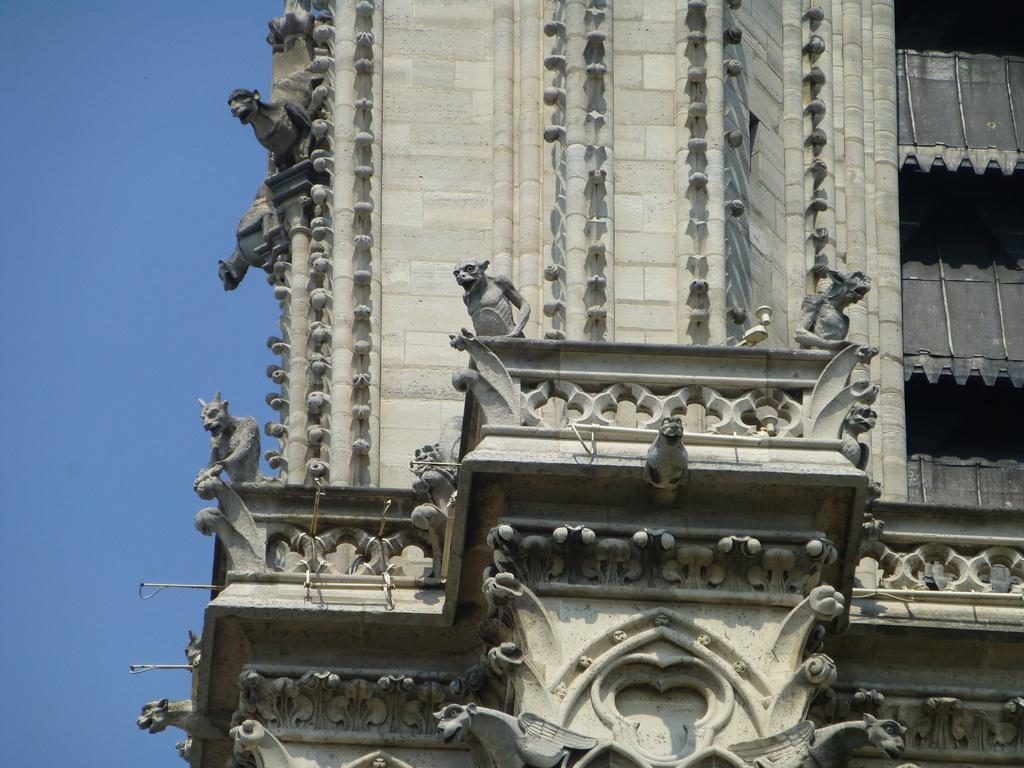What type of structure is present in the image? There is a building in the image. What can be seen in the background of the image? The sky is visible in the background of the image. What type of screw is holding the building together in the image? There is no screw visible in the image, and the building's construction is not mentioned. What action is taking place in the image? The image does not depict any specific action or event. 